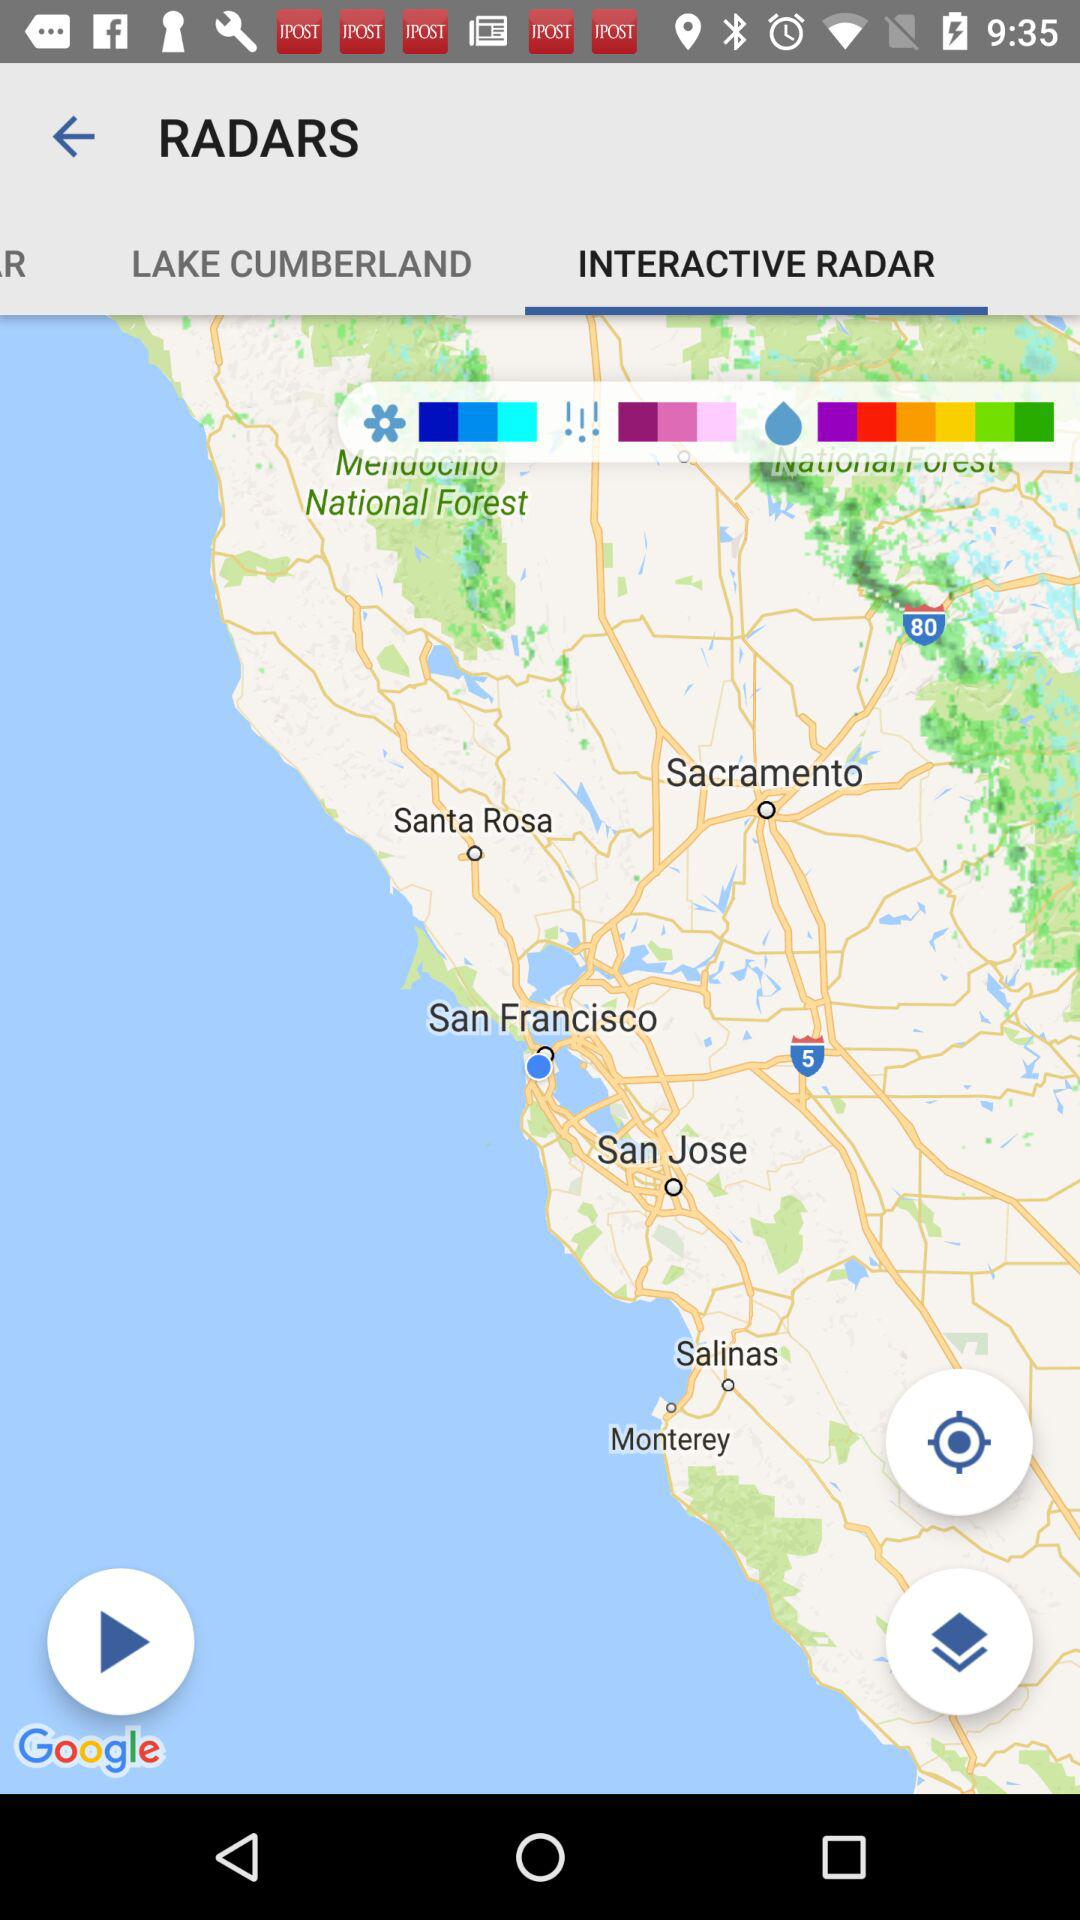Which tab is selected? The selected tab is "INTERACTIVE RADAR". 